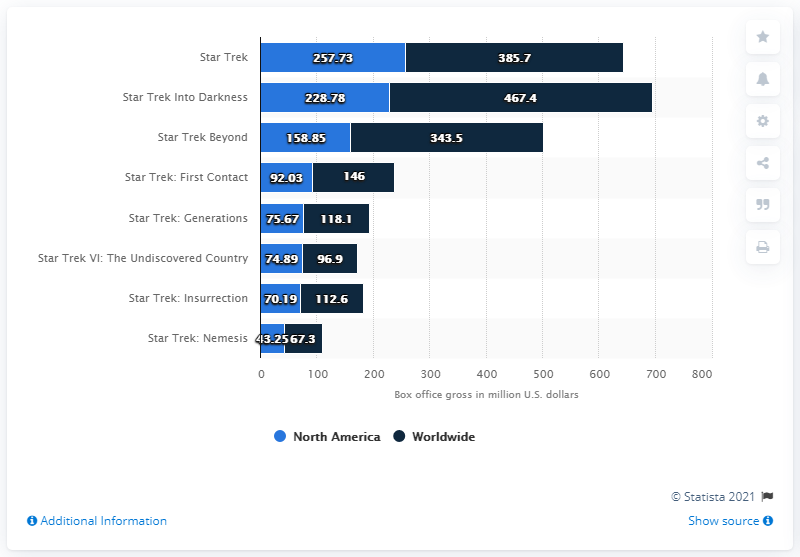Give some essential details in this illustration. As of March 2017, the gross of Star Trek: Insurrection was 70.19 million dollars. 